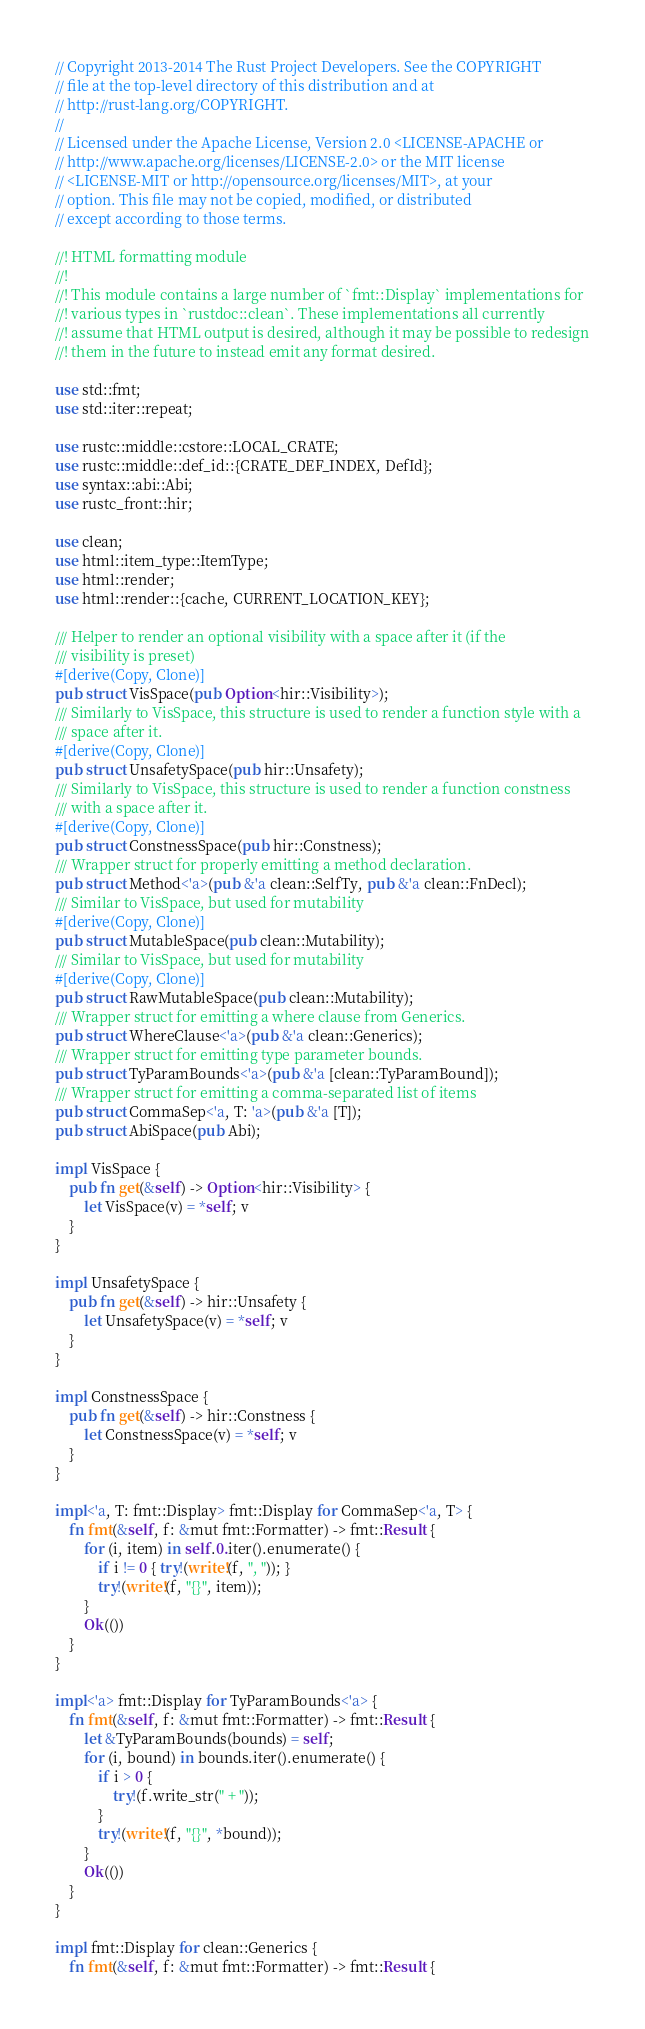Convert code to text. <code><loc_0><loc_0><loc_500><loc_500><_Rust_>// Copyright 2013-2014 The Rust Project Developers. See the COPYRIGHT
// file at the top-level directory of this distribution and at
// http://rust-lang.org/COPYRIGHT.
//
// Licensed under the Apache License, Version 2.0 <LICENSE-APACHE or
// http://www.apache.org/licenses/LICENSE-2.0> or the MIT license
// <LICENSE-MIT or http://opensource.org/licenses/MIT>, at your
// option. This file may not be copied, modified, or distributed
// except according to those terms.

//! HTML formatting module
//!
//! This module contains a large number of `fmt::Display` implementations for
//! various types in `rustdoc::clean`. These implementations all currently
//! assume that HTML output is desired, although it may be possible to redesign
//! them in the future to instead emit any format desired.

use std::fmt;
use std::iter::repeat;

use rustc::middle::cstore::LOCAL_CRATE;
use rustc::middle::def_id::{CRATE_DEF_INDEX, DefId};
use syntax::abi::Abi;
use rustc_front::hir;

use clean;
use html::item_type::ItemType;
use html::render;
use html::render::{cache, CURRENT_LOCATION_KEY};

/// Helper to render an optional visibility with a space after it (if the
/// visibility is preset)
#[derive(Copy, Clone)]
pub struct VisSpace(pub Option<hir::Visibility>);
/// Similarly to VisSpace, this structure is used to render a function style with a
/// space after it.
#[derive(Copy, Clone)]
pub struct UnsafetySpace(pub hir::Unsafety);
/// Similarly to VisSpace, this structure is used to render a function constness
/// with a space after it.
#[derive(Copy, Clone)]
pub struct ConstnessSpace(pub hir::Constness);
/// Wrapper struct for properly emitting a method declaration.
pub struct Method<'a>(pub &'a clean::SelfTy, pub &'a clean::FnDecl);
/// Similar to VisSpace, but used for mutability
#[derive(Copy, Clone)]
pub struct MutableSpace(pub clean::Mutability);
/// Similar to VisSpace, but used for mutability
#[derive(Copy, Clone)]
pub struct RawMutableSpace(pub clean::Mutability);
/// Wrapper struct for emitting a where clause from Generics.
pub struct WhereClause<'a>(pub &'a clean::Generics);
/// Wrapper struct for emitting type parameter bounds.
pub struct TyParamBounds<'a>(pub &'a [clean::TyParamBound]);
/// Wrapper struct for emitting a comma-separated list of items
pub struct CommaSep<'a, T: 'a>(pub &'a [T]);
pub struct AbiSpace(pub Abi);

impl VisSpace {
    pub fn get(&self) -> Option<hir::Visibility> {
        let VisSpace(v) = *self; v
    }
}

impl UnsafetySpace {
    pub fn get(&self) -> hir::Unsafety {
        let UnsafetySpace(v) = *self; v
    }
}

impl ConstnessSpace {
    pub fn get(&self) -> hir::Constness {
        let ConstnessSpace(v) = *self; v
    }
}

impl<'a, T: fmt::Display> fmt::Display for CommaSep<'a, T> {
    fn fmt(&self, f: &mut fmt::Formatter) -> fmt::Result {
        for (i, item) in self.0.iter().enumerate() {
            if i != 0 { try!(write!(f, ", ")); }
            try!(write!(f, "{}", item));
        }
        Ok(())
    }
}

impl<'a> fmt::Display for TyParamBounds<'a> {
    fn fmt(&self, f: &mut fmt::Formatter) -> fmt::Result {
        let &TyParamBounds(bounds) = self;
        for (i, bound) in bounds.iter().enumerate() {
            if i > 0 {
                try!(f.write_str(" + "));
            }
            try!(write!(f, "{}", *bound));
        }
        Ok(())
    }
}

impl fmt::Display for clean::Generics {
    fn fmt(&self, f: &mut fmt::Formatter) -> fmt::Result {</code> 